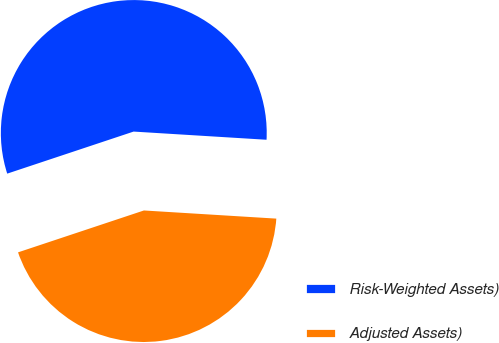<chart> <loc_0><loc_0><loc_500><loc_500><pie_chart><fcel>Risk-Weighted Assets)<fcel>Adjusted Assets)<nl><fcel>56.09%<fcel>43.91%<nl></chart> 